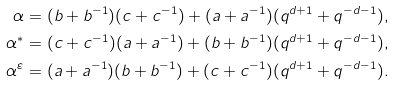Convert formula to latex. <formula><loc_0><loc_0><loc_500><loc_500>\alpha & = ( b + b ^ { - 1 } ) ( c + c ^ { - 1 } ) + ( a + a ^ { - 1 } ) ( q ^ { d + 1 } + q ^ { - d - 1 } ) , \\ \alpha ^ { * } & = ( c + c ^ { - 1 } ) ( a + a ^ { - 1 } ) + ( b + b ^ { - 1 } ) ( q ^ { d + 1 } + q ^ { - d - 1 } ) , \\ \alpha ^ { \varepsilon } & = ( a + a ^ { - 1 } ) ( b + b ^ { - 1 } ) + ( c + c ^ { - 1 } ) ( q ^ { d + 1 } + q ^ { - d - 1 } ) .</formula> 